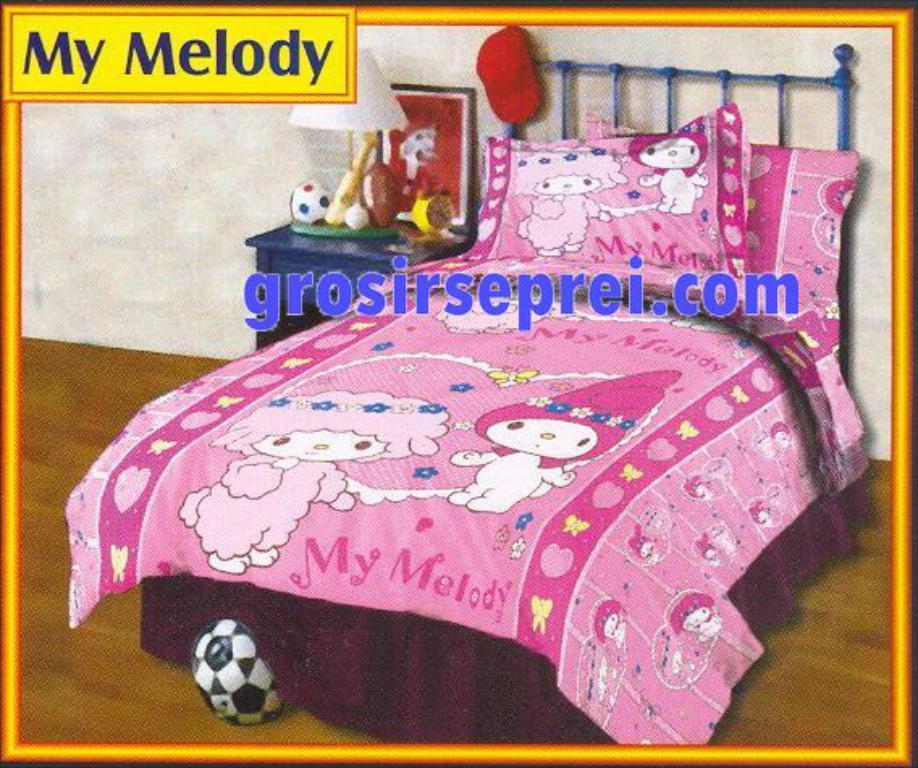Please provide a concise description of this image. This picture consists of photo frame , in the frame there is a bed and bed sheet, pillow, beside the bed there is a small table , on the table there is a ball,photo frame,bat,lamp visible and there is a red color cap attached to the cot, in front of cot there is a ball at bottom,at the top there is a text and the wall visible back side of bed. 